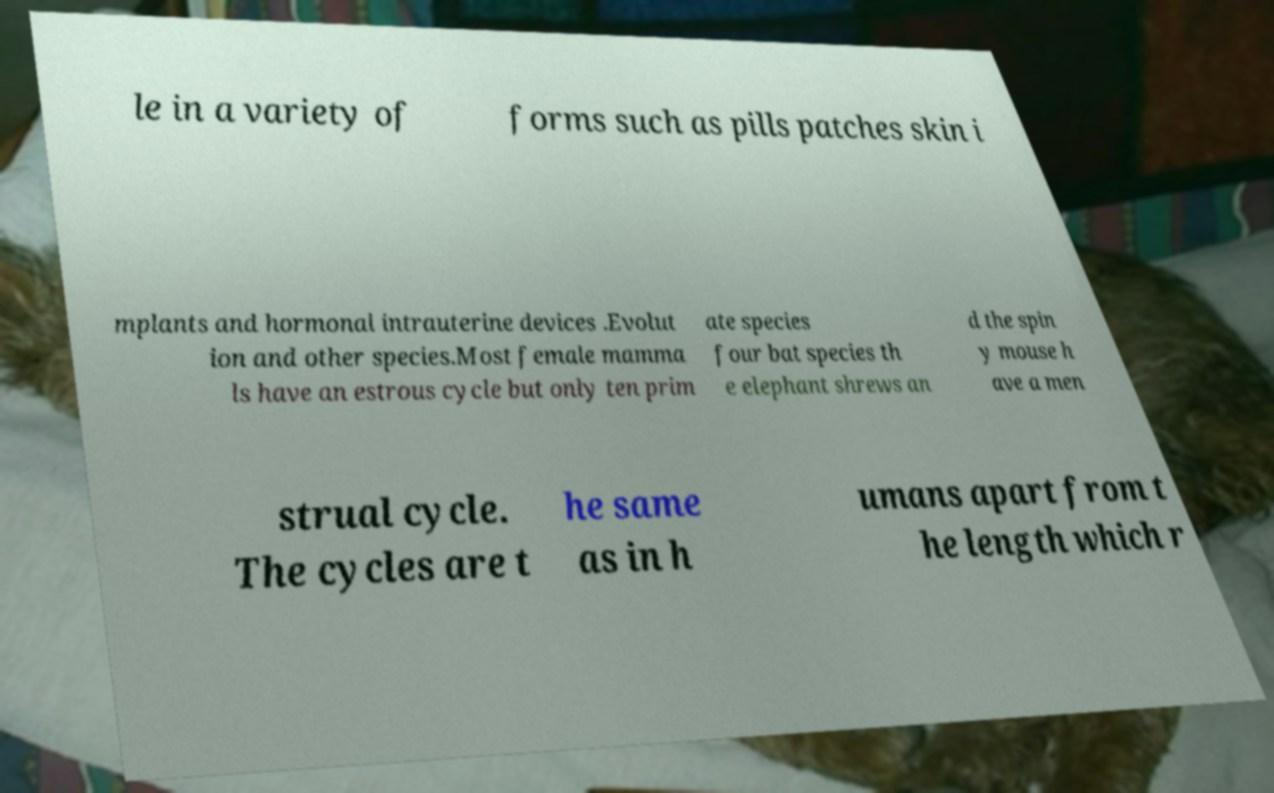Please read and relay the text visible in this image. What does it say? le in a variety of forms such as pills patches skin i mplants and hormonal intrauterine devices .Evolut ion and other species.Most female mamma ls have an estrous cycle but only ten prim ate species four bat species th e elephant shrews an d the spin y mouse h ave a men strual cycle. The cycles are t he same as in h umans apart from t he length which r 